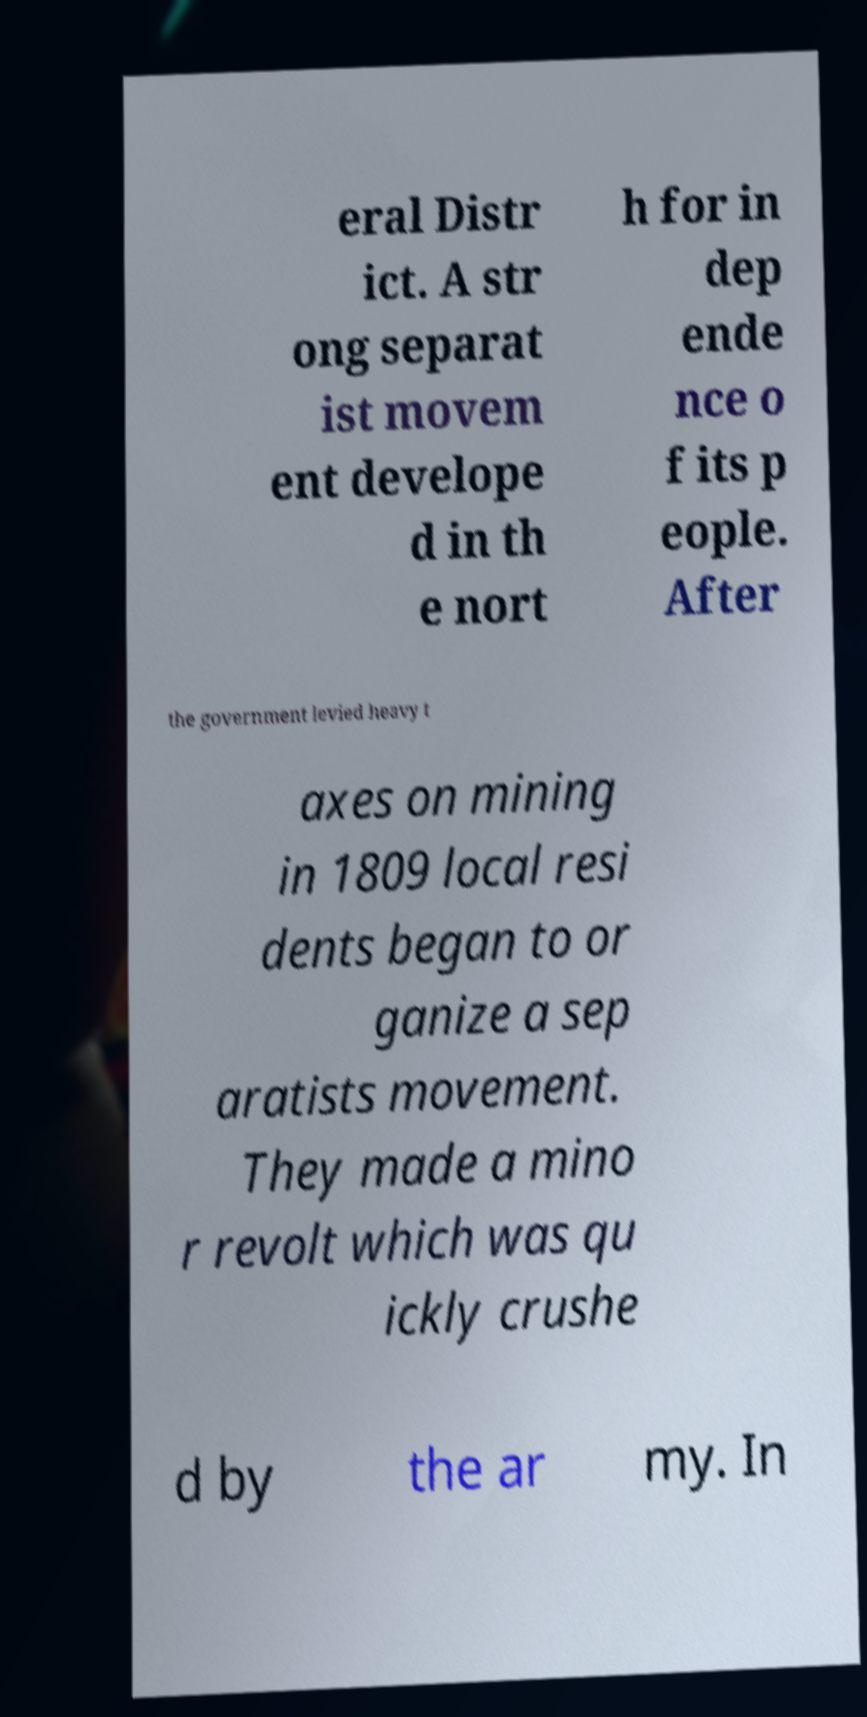Please identify and transcribe the text found in this image. eral Distr ict. A str ong separat ist movem ent develope d in th e nort h for in dep ende nce o f its p eople. After the government levied heavy t axes on mining in 1809 local resi dents began to or ganize a sep aratists movement. They made a mino r revolt which was qu ickly crushe d by the ar my. In 